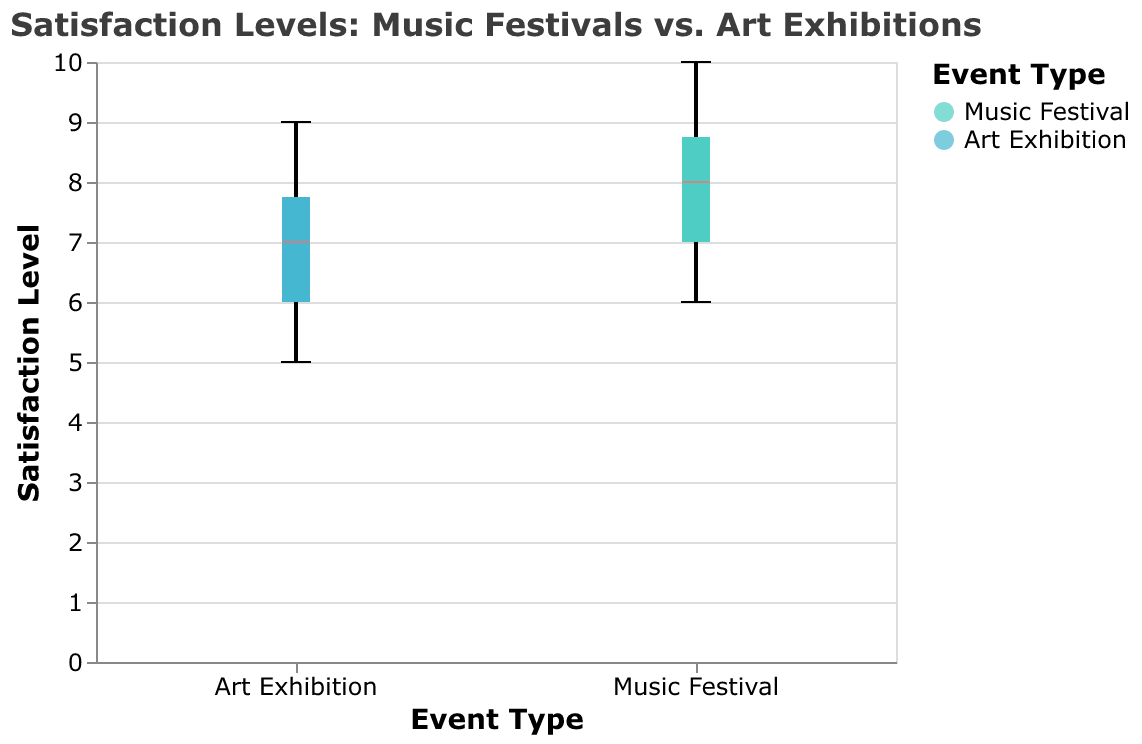What is the title of the figure? The title of the figure is clearly displayed at the top. It states, "Satisfaction Levels: Music Festivals vs. Art Exhibitions".
Answer: Satisfaction Levels: Music Festivals vs. Art Exhibitions What is the range of the y-axis? The y-axis represents the Satisfaction Level, and the scale is set from 0 to 10, which is evident from inspecting the axis labels.
Answer: 0 to 10 What colors represent the Music Festival and Art Exhibition groups? The colors for each group are shown in the legend. Music Festivals are represented by a teal color, while Art Exhibitions are depicted in blue.
Answer: Teal for Music Festival, blue for Art Exhibition What is the median satisfaction level for Music Festivals? Look at the midpoint of the Music Festival boxplot, which is indicated by the median line in red.
Answer: 8 Which group shows a wider spread in satisfaction levels? Examine the length of the boxes and the whiskers for each group. The group with a longer box and whiskers has a wider spread in satisfaction levels. Visually, Music Festivals have a broader range.
Answer: Music Festivals What is the minimum satisfaction level in the Art Exhibition group? The minimum satisfaction level is represented by the bottom whisker of the Art Exhibition boxplot. It reaches down to a satisfaction level of 5.
Answer: 5 Which group has a higher maximum satisfaction level? Observe the top whisker of both boxplots. The Music Festival whisker reaches higher, indicating a maximum satisfaction level of 10, whereas Art Exhibition reaches 9.
Answer: Music Festivals Is the median satisfaction level for Music Festivals higher than for Art Exhibitions? Compare the red median lines of both boxplots. The median for Music Festivals is at 8, while for Art Exhibitions it is at 7.
Answer: Yes What is the interquartile range (IQR) for Art Exhibitions? The IQR is the distance between the first quartile (Q1) and the third quartile (Q3). For Art Exhibitions, Q1 is at 6 and Q3 is at 8. Therefore, IQR = 8 - 6.
Answer: 2 Which event type has more consistent satisfaction levels? Consistency can be judged by the range and spread of the data. Art Exhibitions have a smaller spread, indicating more consistent satisfaction levels.
Answer: Art Exhibitions 